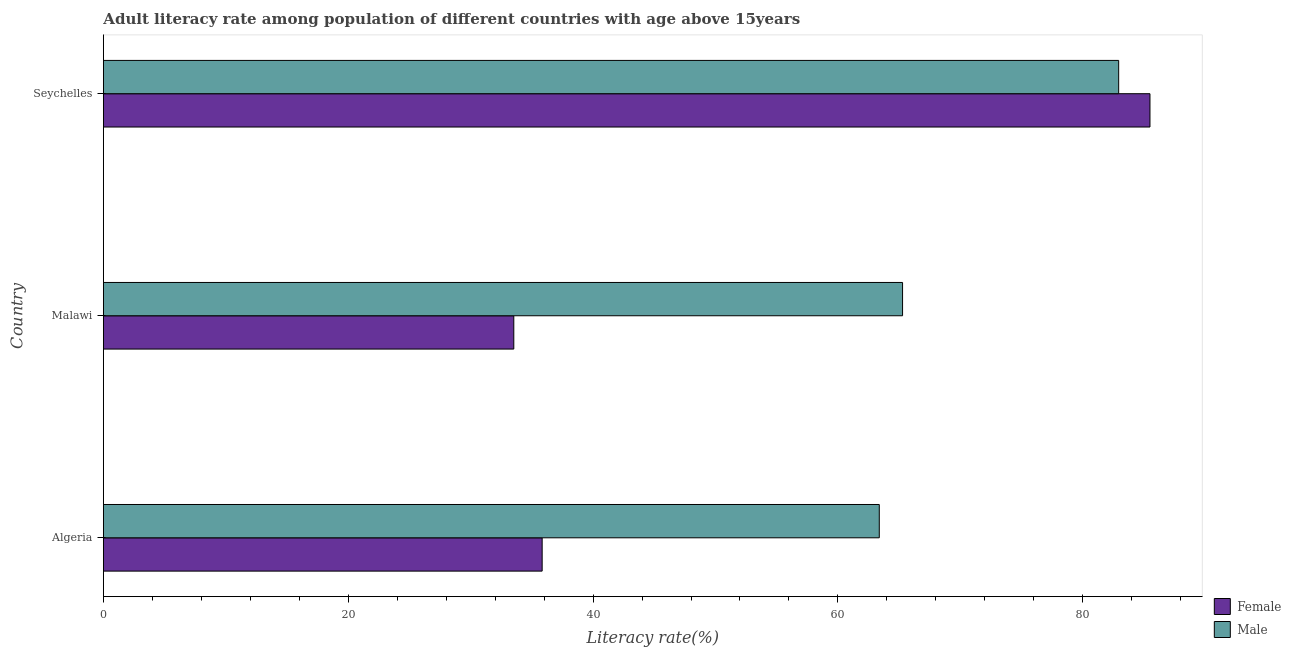Are the number of bars per tick equal to the number of legend labels?
Offer a terse response. Yes. How many bars are there on the 1st tick from the top?
Give a very brief answer. 2. What is the label of the 3rd group of bars from the top?
Ensure brevity in your answer.  Algeria. In how many cases, is the number of bars for a given country not equal to the number of legend labels?
Offer a terse response. 0. What is the male adult literacy rate in Seychelles?
Provide a succinct answer. 82.93. Across all countries, what is the maximum male adult literacy rate?
Give a very brief answer. 82.93. Across all countries, what is the minimum male adult literacy rate?
Offer a very short reply. 63.38. In which country was the male adult literacy rate maximum?
Make the answer very short. Seychelles. In which country was the male adult literacy rate minimum?
Give a very brief answer. Algeria. What is the total male adult literacy rate in the graph?
Give a very brief answer. 211.59. What is the difference between the female adult literacy rate in Algeria and that in Seychelles?
Provide a succinct answer. -49.65. What is the difference between the male adult literacy rate in Seychelles and the female adult literacy rate in Malawi?
Offer a terse response. 49.41. What is the average female adult literacy rate per country?
Make the answer very short. 51.62. What is the difference between the male adult literacy rate and female adult literacy rate in Malawi?
Your response must be concise. 31.76. In how many countries, is the male adult literacy rate greater than 40 %?
Give a very brief answer. 3. What is the ratio of the male adult literacy rate in Algeria to that in Seychelles?
Provide a succinct answer. 0.76. What is the difference between the highest and the second highest male adult literacy rate?
Offer a terse response. 17.65. What is the difference between the highest and the lowest male adult literacy rate?
Offer a terse response. 19.55. In how many countries, is the male adult literacy rate greater than the average male adult literacy rate taken over all countries?
Make the answer very short. 1. Is the sum of the male adult literacy rate in Algeria and Seychelles greater than the maximum female adult literacy rate across all countries?
Offer a very short reply. Yes. What does the 2nd bar from the top in Seychelles represents?
Make the answer very short. Female. What does the 1st bar from the bottom in Algeria represents?
Make the answer very short. Female. How many countries are there in the graph?
Offer a very short reply. 3. What is the difference between two consecutive major ticks on the X-axis?
Provide a succinct answer. 20. Does the graph contain any zero values?
Provide a short and direct response. No. Does the graph contain grids?
Provide a succinct answer. No. How are the legend labels stacked?
Give a very brief answer. Vertical. What is the title of the graph?
Provide a succinct answer. Adult literacy rate among population of different countries with age above 15years. What is the label or title of the X-axis?
Your response must be concise. Literacy rate(%). What is the label or title of the Y-axis?
Provide a succinct answer. Country. What is the Literacy rate(%) of Female in Algeria?
Keep it short and to the point. 35.84. What is the Literacy rate(%) in Male in Algeria?
Offer a terse response. 63.38. What is the Literacy rate(%) of Female in Malawi?
Offer a very short reply. 33.52. What is the Literacy rate(%) in Male in Malawi?
Offer a terse response. 65.28. What is the Literacy rate(%) of Female in Seychelles?
Your answer should be compact. 85.49. What is the Literacy rate(%) in Male in Seychelles?
Give a very brief answer. 82.93. Across all countries, what is the maximum Literacy rate(%) in Female?
Provide a short and direct response. 85.49. Across all countries, what is the maximum Literacy rate(%) in Male?
Keep it short and to the point. 82.93. Across all countries, what is the minimum Literacy rate(%) in Female?
Keep it short and to the point. 33.52. Across all countries, what is the minimum Literacy rate(%) of Male?
Give a very brief answer. 63.38. What is the total Literacy rate(%) in Female in the graph?
Provide a short and direct response. 154.85. What is the total Literacy rate(%) in Male in the graph?
Offer a very short reply. 211.59. What is the difference between the Literacy rate(%) of Female in Algeria and that in Malawi?
Provide a succinct answer. 2.32. What is the difference between the Literacy rate(%) in Male in Algeria and that in Malawi?
Your answer should be very brief. -1.9. What is the difference between the Literacy rate(%) of Female in Algeria and that in Seychelles?
Ensure brevity in your answer.  -49.65. What is the difference between the Literacy rate(%) of Male in Algeria and that in Seychelles?
Give a very brief answer. -19.55. What is the difference between the Literacy rate(%) in Female in Malawi and that in Seychelles?
Your answer should be very brief. -51.97. What is the difference between the Literacy rate(%) of Male in Malawi and that in Seychelles?
Provide a short and direct response. -17.65. What is the difference between the Literacy rate(%) of Female in Algeria and the Literacy rate(%) of Male in Malawi?
Make the answer very short. -29.44. What is the difference between the Literacy rate(%) in Female in Algeria and the Literacy rate(%) in Male in Seychelles?
Offer a very short reply. -47.09. What is the difference between the Literacy rate(%) of Female in Malawi and the Literacy rate(%) of Male in Seychelles?
Give a very brief answer. -49.41. What is the average Literacy rate(%) in Female per country?
Your response must be concise. 51.62. What is the average Literacy rate(%) in Male per country?
Ensure brevity in your answer.  70.53. What is the difference between the Literacy rate(%) of Female and Literacy rate(%) of Male in Algeria?
Provide a succinct answer. -27.54. What is the difference between the Literacy rate(%) in Female and Literacy rate(%) in Male in Malawi?
Your answer should be very brief. -31.76. What is the difference between the Literacy rate(%) of Female and Literacy rate(%) of Male in Seychelles?
Provide a short and direct response. 2.56. What is the ratio of the Literacy rate(%) in Female in Algeria to that in Malawi?
Your answer should be very brief. 1.07. What is the ratio of the Literacy rate(%) in Male in Algeria to that in Malawi?
Provide a succinct answer. 0.97. What is the ratio of the Literacy rate(%) in Female in Algeria to that in Seychelles?
Give a very brief answer. 0.42. What is the ratio of the Literacy rate(%) of Male in Algeria to that in Seychelles?
Provide a succinct answer. 0.76. What is the ratio of the Literacy rate(%) in Female in Malawi to that in Seychelles?
Your response must be concise. 0.39. What is the ratio of the Literacy rate(%) in Male in Malawi to that in Seychelles?
Keep it short and to the point. 0.79. What is the difference between the highest and the second highest Literacy rate(%) of Female?
Your response must be concise. 49.65. What is the difference between the highest and the second highest Literacy rate(%) of Male?
Provide a succinct answer. 17.65. What is the difference between the highest and the lowest Literacy rate(%) in Female?
Your response must be concise. 51.97. What is the difference between the highest and the lowest Literacy rate(%) in Male?
Your answer should be very brief. 19.55. 